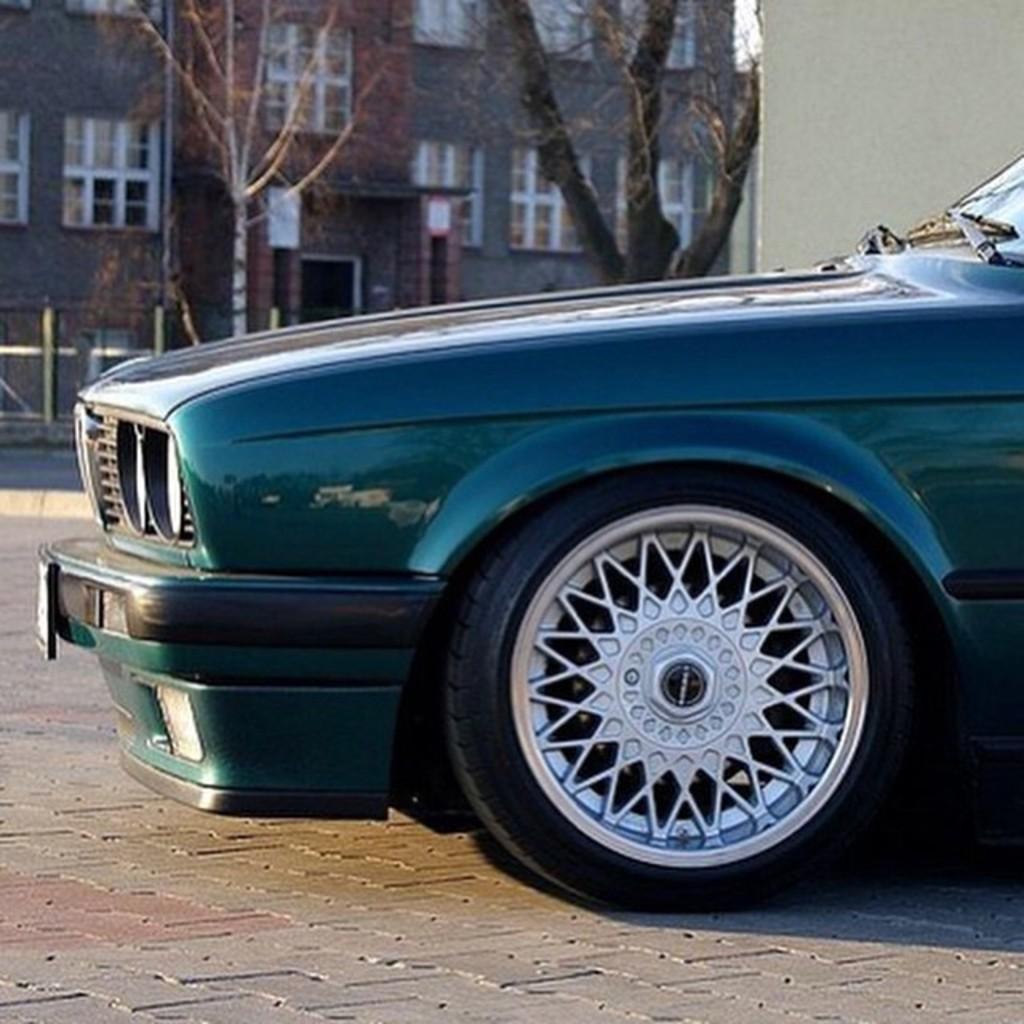Can you describe this image briefly? In the center of the image we can see car on the road. In the background we can see trees and building. 